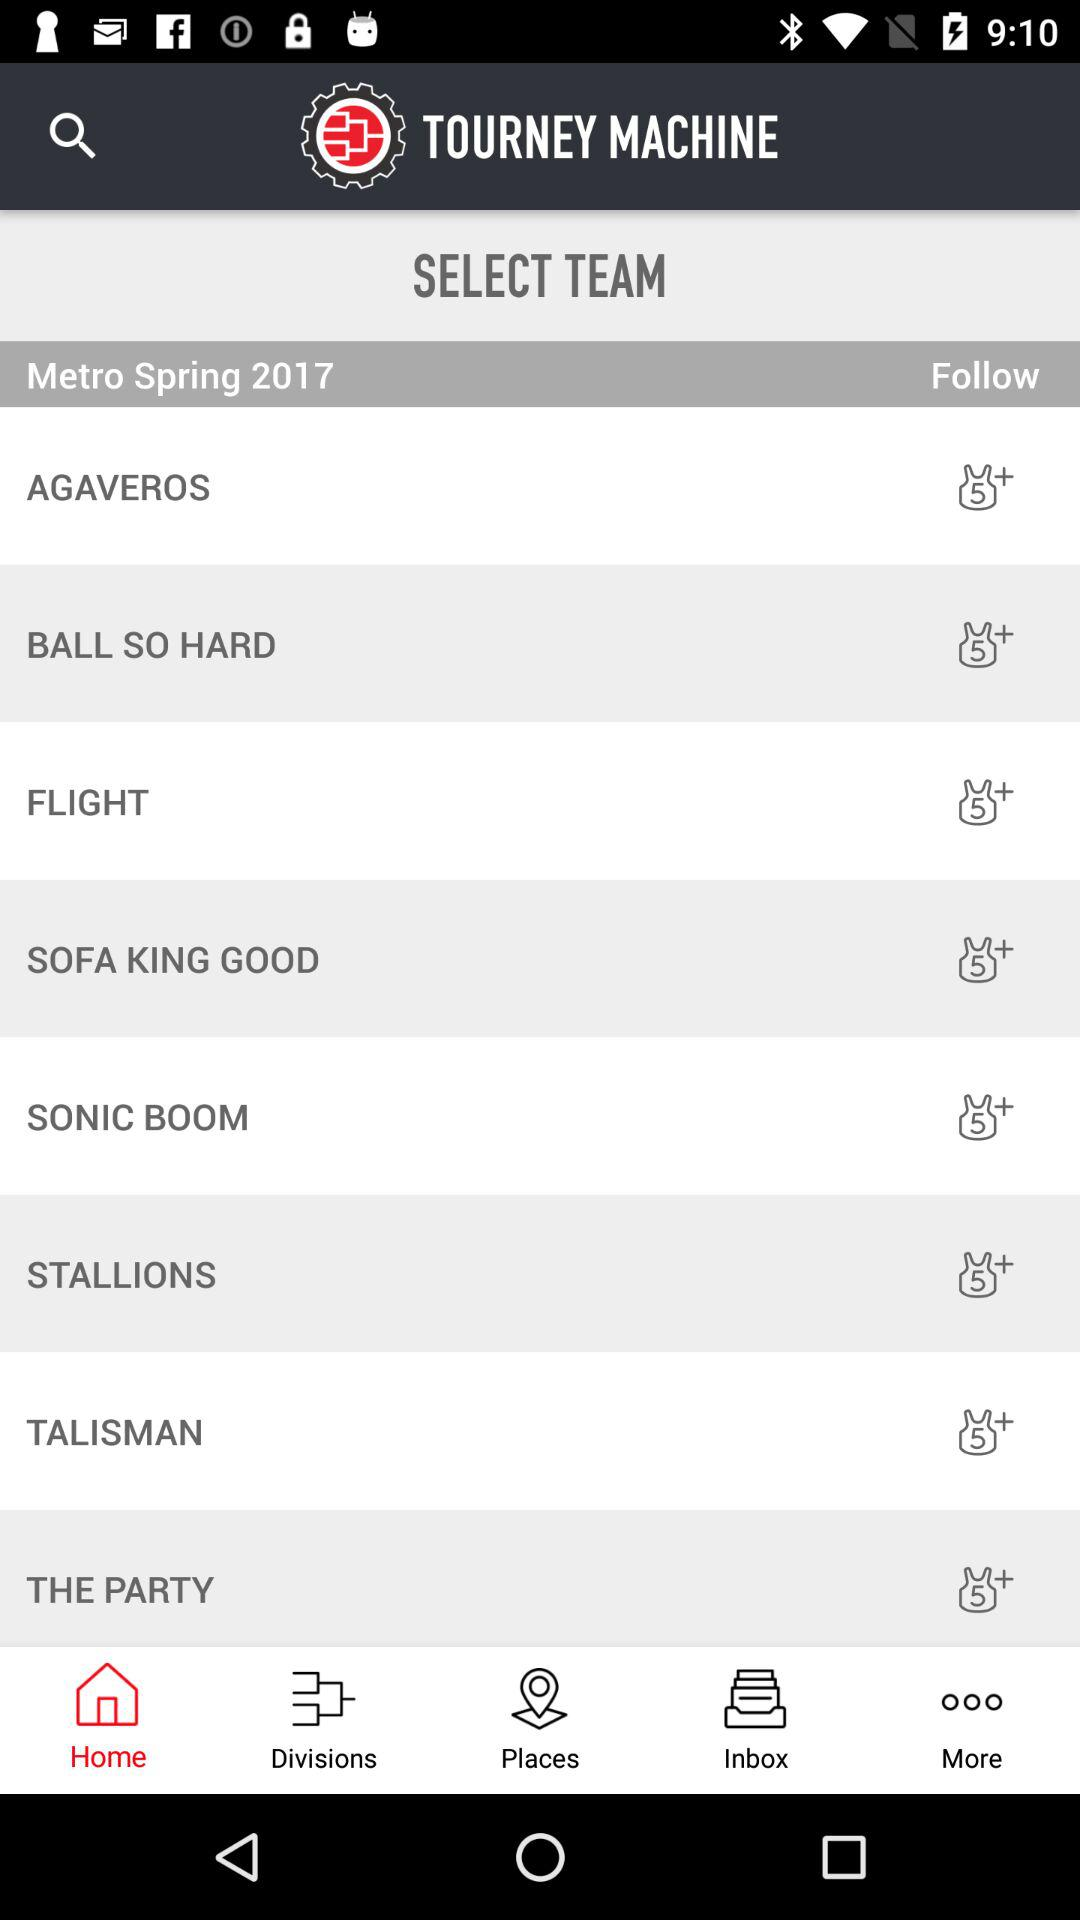What is the application name? The application name is "TOURNEY MACHINE". 